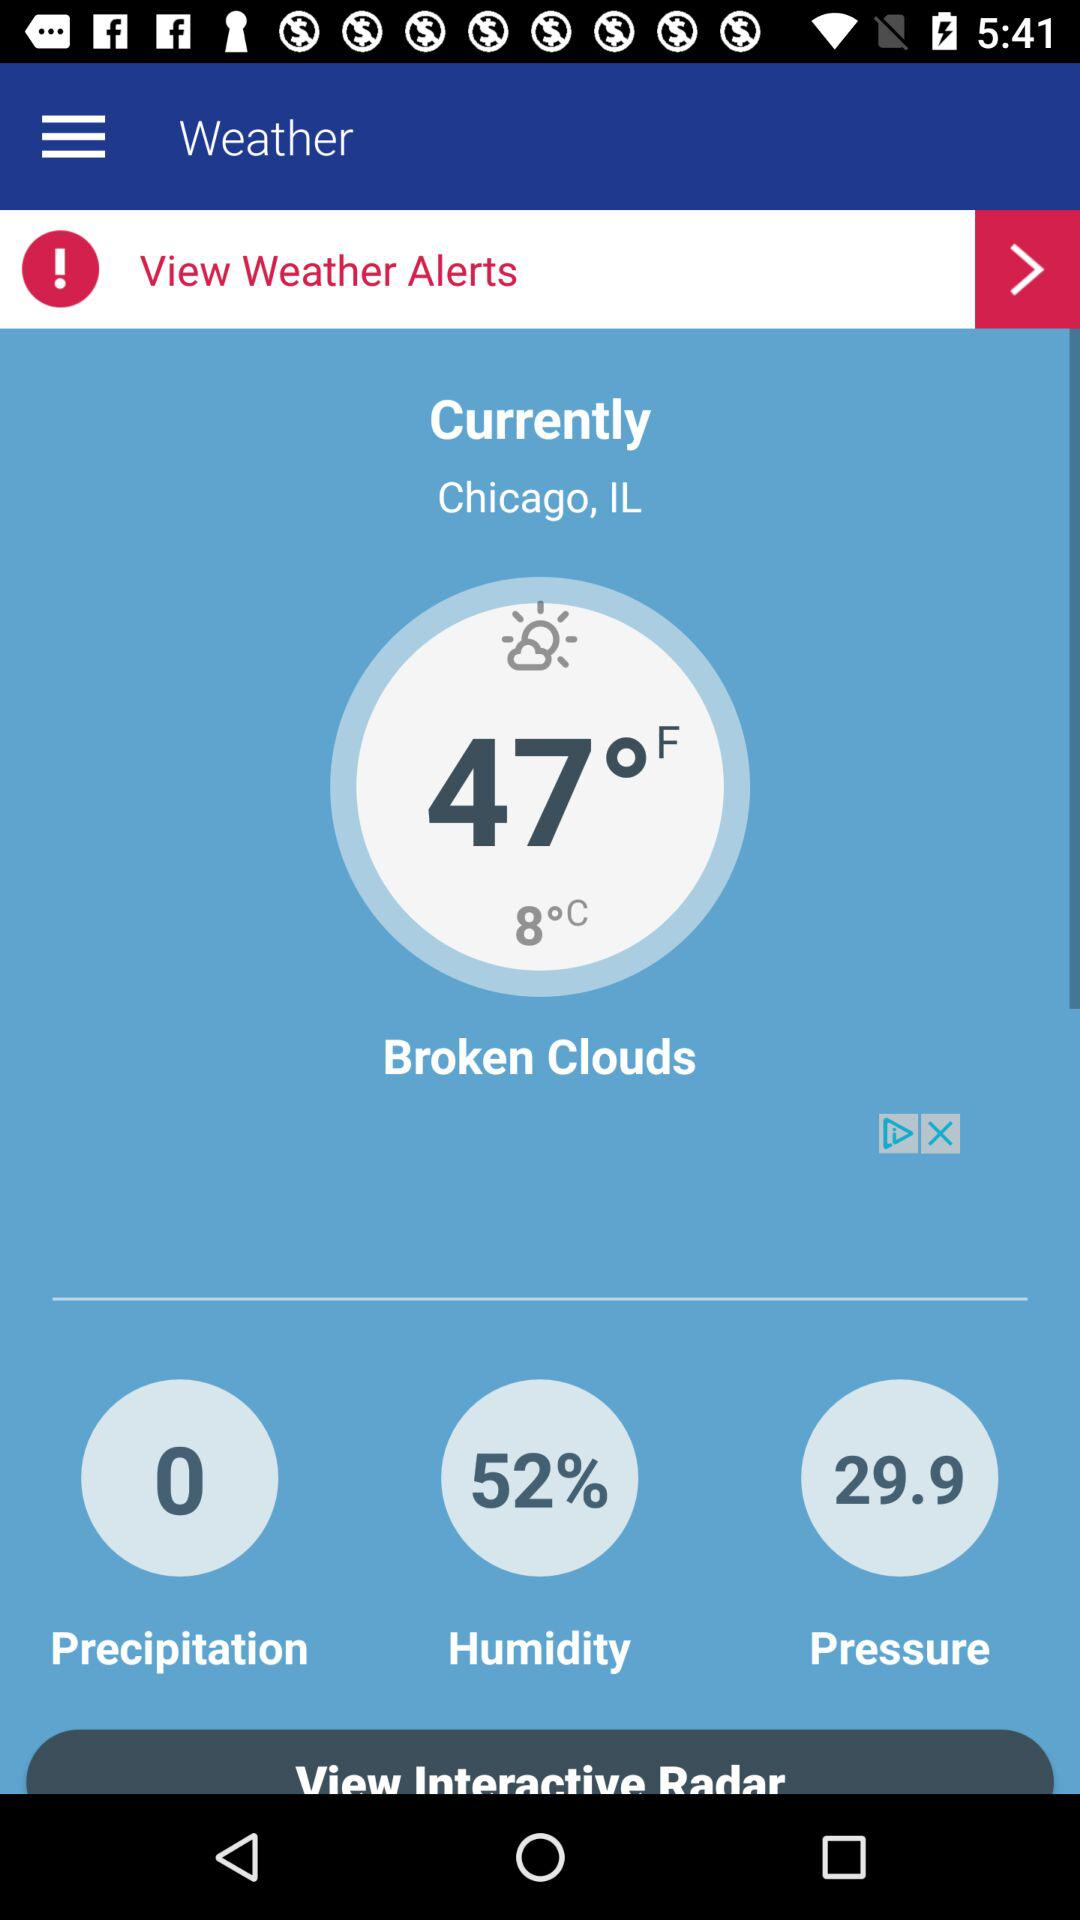What is the temperature? The temperature is 47 degrees Fahrenheit (8 degrees Celsius). 